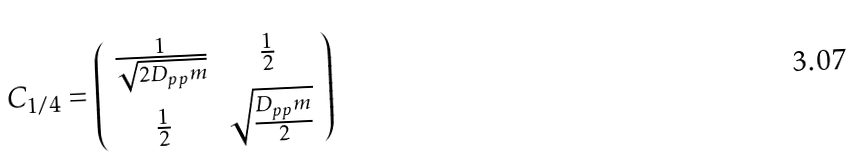Convert formula to latex. <formula><loc_0><loc_0><loc_500><loc_500>C _ { 1 / 4 } = \left ( \begin{array} { c c } \frac { 1 } { \sqrt { 2 D _ { p p } m } } & \frac { 1 } { 2 } \\ \frac { 1 } { 2 } & \sqrt { \frac { D _ { p p } m } { 2 } } \end{array} \right )</formula> 